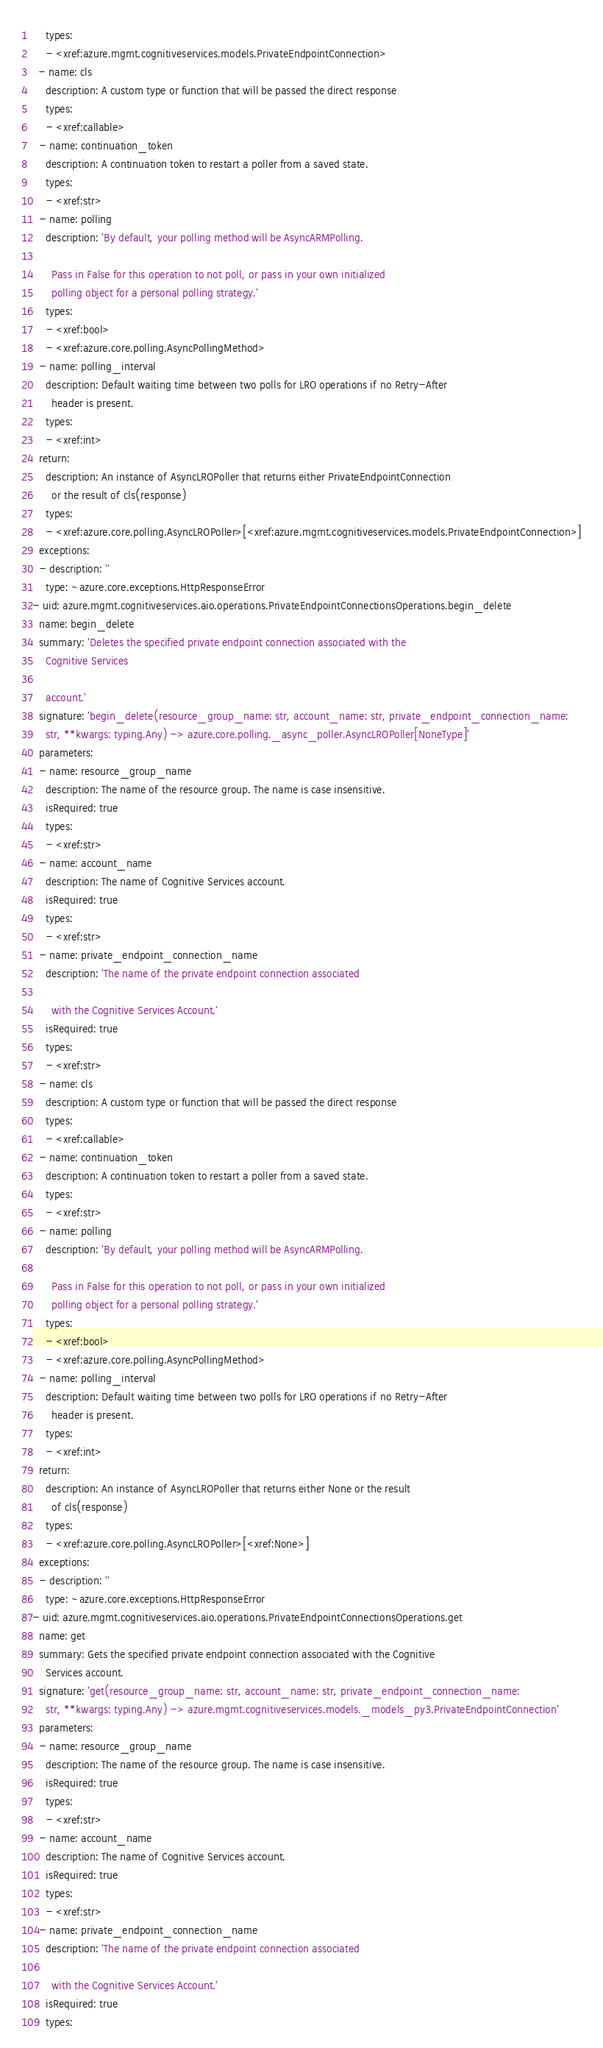<code> <loc_0><loc_0><loc_500><loc_500><_YAML_>    types:
    - <xref:azure.mgmt.cognitiveservices.models.PrivateEndpointConnection>
  - name: cls
    description: A custom type or function that will be passed the direct response
    types:
    - <xref:callable>
  - name: continuation_token
    description: A continuation token to restart a poller from a saved state.
    types:
    - <xref:str>
  - name: polling
    description: 'By default, your polling method will be AsyncARMPolling.

      Pass in False for this operation to not poll, or pass in your own initialized
      polling object for a personal polling strategy.'
    types:
    - <xref:bool>
    - <xref:azure.core.polling.AsyncPollingMethod>
  - name: polling_interval
    description: Default waiting time between two polls for LRO operations if no Retry-After
      header is present.
    types:
    - <xref:int>
  return:
    description: An instance of AsyncLROPoller that returns either PrivateEndpointConnection
      or the result of cls(response)
    types:
    - <xref:azure.core.polling.AsyncLROPoller>[<xref:azure.mgmt.cognitiveservices.models.PrivateEndpointConnection>]
  exceptions:
  - description: ''
    type: ~azure.core.exceptions.HttpResponseError
- uid: azure.mgmt.cognitiveservices.aio.operations.PrivateEndpointConnectionsOperations.begin_delete
  name: begin_delete
  summary: 'Deletes the specified private endpoint connection associated with the
    Cognitive Services

    account.'
  signature: 'begin_delete(resource_group_name: str, account_name: str, private_endpoint_connection_name:
    str, **kwargs: typing.Any) -> azure.core.polling._async_poller.AsyncLROPoller[NoneType]'
  parameters:
  - name: resource_group_name
    description: The name of the resource group. The name is case insensitive.
    isRequired: true
    types:
    - <xref:str>
  - name: account_name
    description: The name of Cognitive Services account.
    isRequired: true
    types:
    - <xref:str>
  - name: private_endpoint_connection_name
    description: 'The name of the private endpoint connection associated

      with the Cognitive Services Account.'
    isRequired: true
    types:
    - <xref:str>
  - name: cls
    description: A custom type or function that will be passed the direct response
    types:
    - <xref:callable>
  - name: continuation_token
    description: A continuation token to restart a poller from a saved state.
    types:
    - <xref:str>
  - name: polling
    description: 'By default, your polling method will be AsyncARMPolling.

      Pass in False for this operation to not poll, or pass in your own initialized
      polling object for a personal polling strategy.'
    types:
    - <xref:bool>
    - <xref:azure.core.polling.AsyncPollingMethod>
  - name: polling_interval
    description: Default waiting time between two polls for LRO operations if no Retry-After
      header is present.
    types:
    - <xref:int>
  return:
    description: An instance of AsyncLROPoller that returns either None or the result
      of cls(response)
    types:
    - <xref:azure.core.polling.AsyncLROPoller>[<xref:None>]
  exceptions:
  - description: ''
    type: ~azure.core.exceptions.HttpResponseError
- uid: azure.mgmt.cognitiveservices.aio.operations.PrivateEndpointConnectionsOperations.get
  name: get
  summary: Gets the specified private endpoint connection associated with the Cognitive
    Services account.
  signature: 'get(resource_group_name: str, account_name: str, private_endpoint_connection_name:
    str, **kwargs: typing.Any) -> azure.mgmt.cognitiveservices.models._models_py3.PrivateEndpointConnection'
  parameters:
  - name: resource_group_name
    description: The name of the resource group. The name is case insensitive.
    isRequired: true
    types:
    - <xref:str>
  - name: account_name
    description: The name of Cognitive Services account.
    isRequired: true
    types:
    - <xref:str>
  - name: private_endpoint_connection_name
    description: 'The name of the private endpoint connection associated

      with the Cognitive Services Account.'
    isRequired: true
    types:</code> 